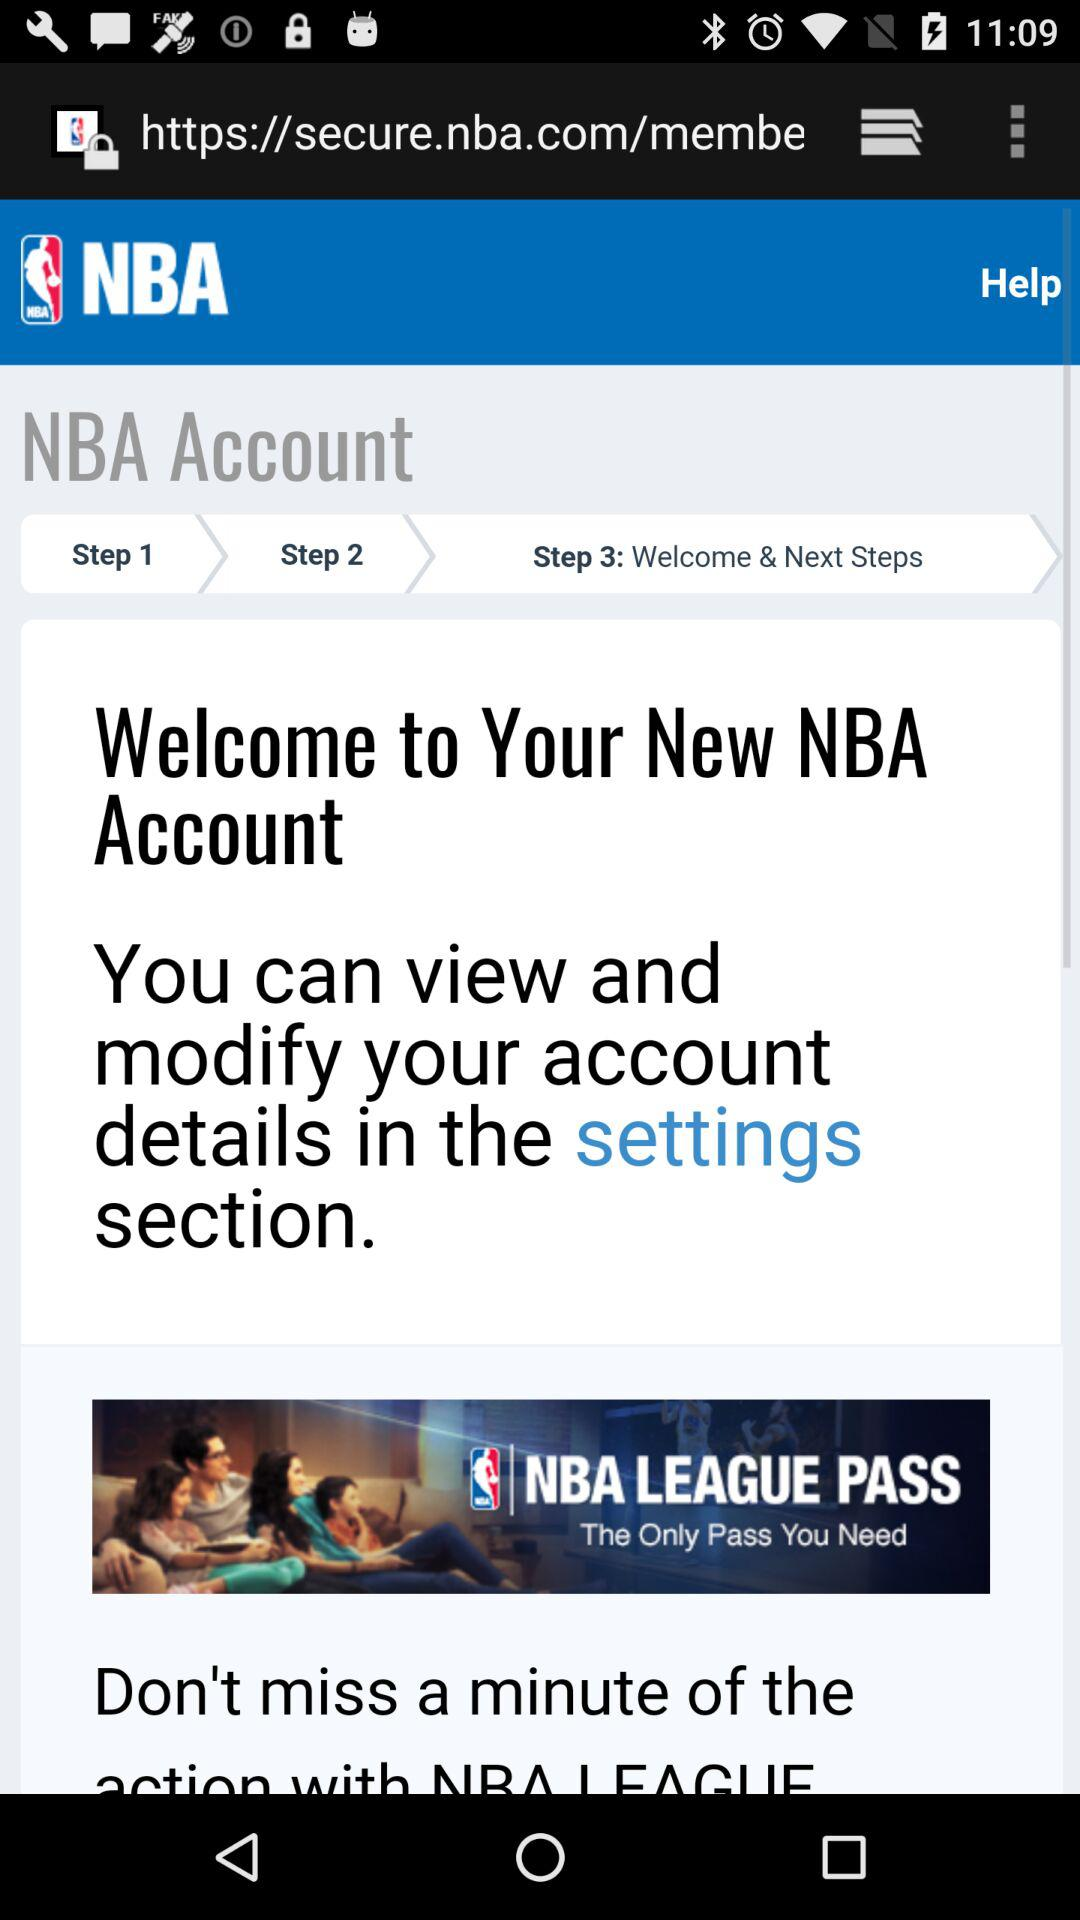How many steps are there in the account setup process?
Answer the question using a single word or phrase. 3 